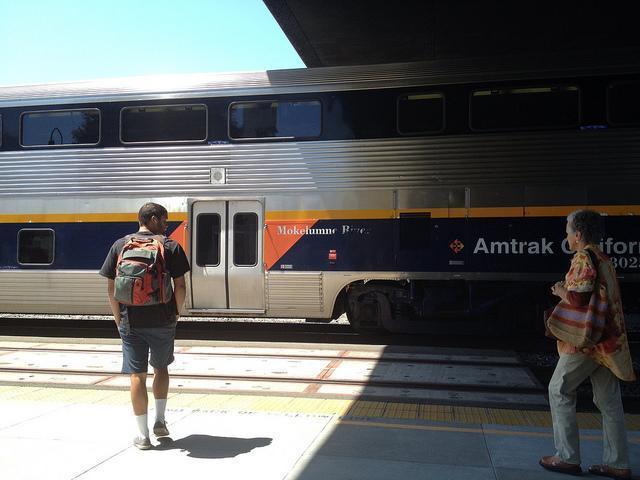How many levels are on the train?
Give a very brief answer. 2. How many people are in the picture?
Give a very brief answer. 2. How many clocks have red numbers?
Give a very brief answer. 0. 